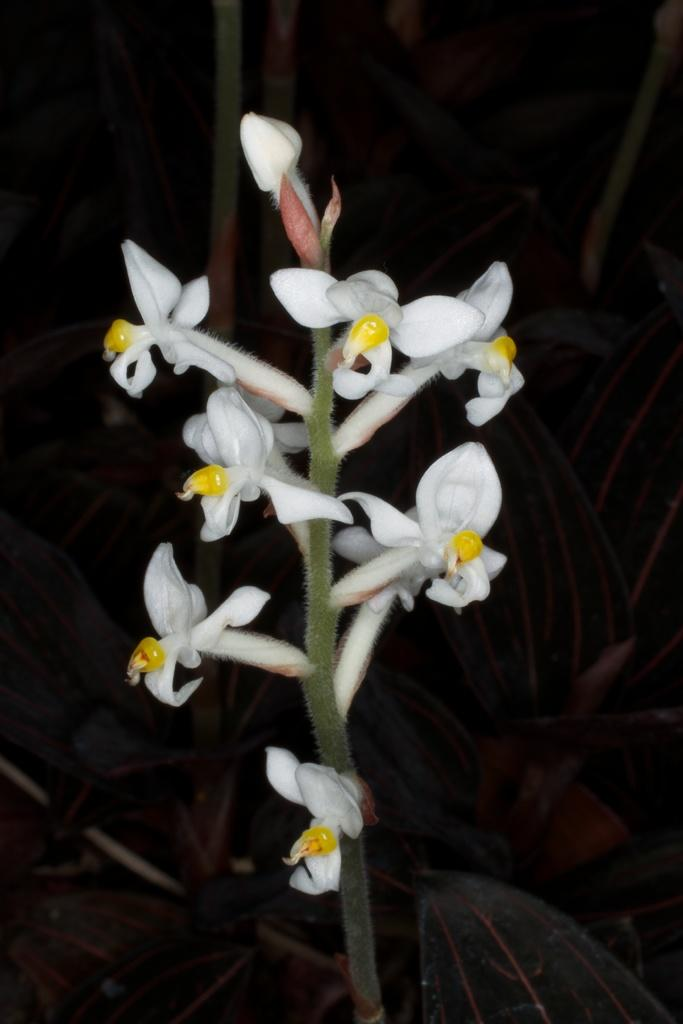What is present in the image? There is a plant in the image. What can be observed about the plant? The plant has flowers. What type of apparel is the plant wearing in the image? There is no apparel present in the image, as the subject is a plant. 